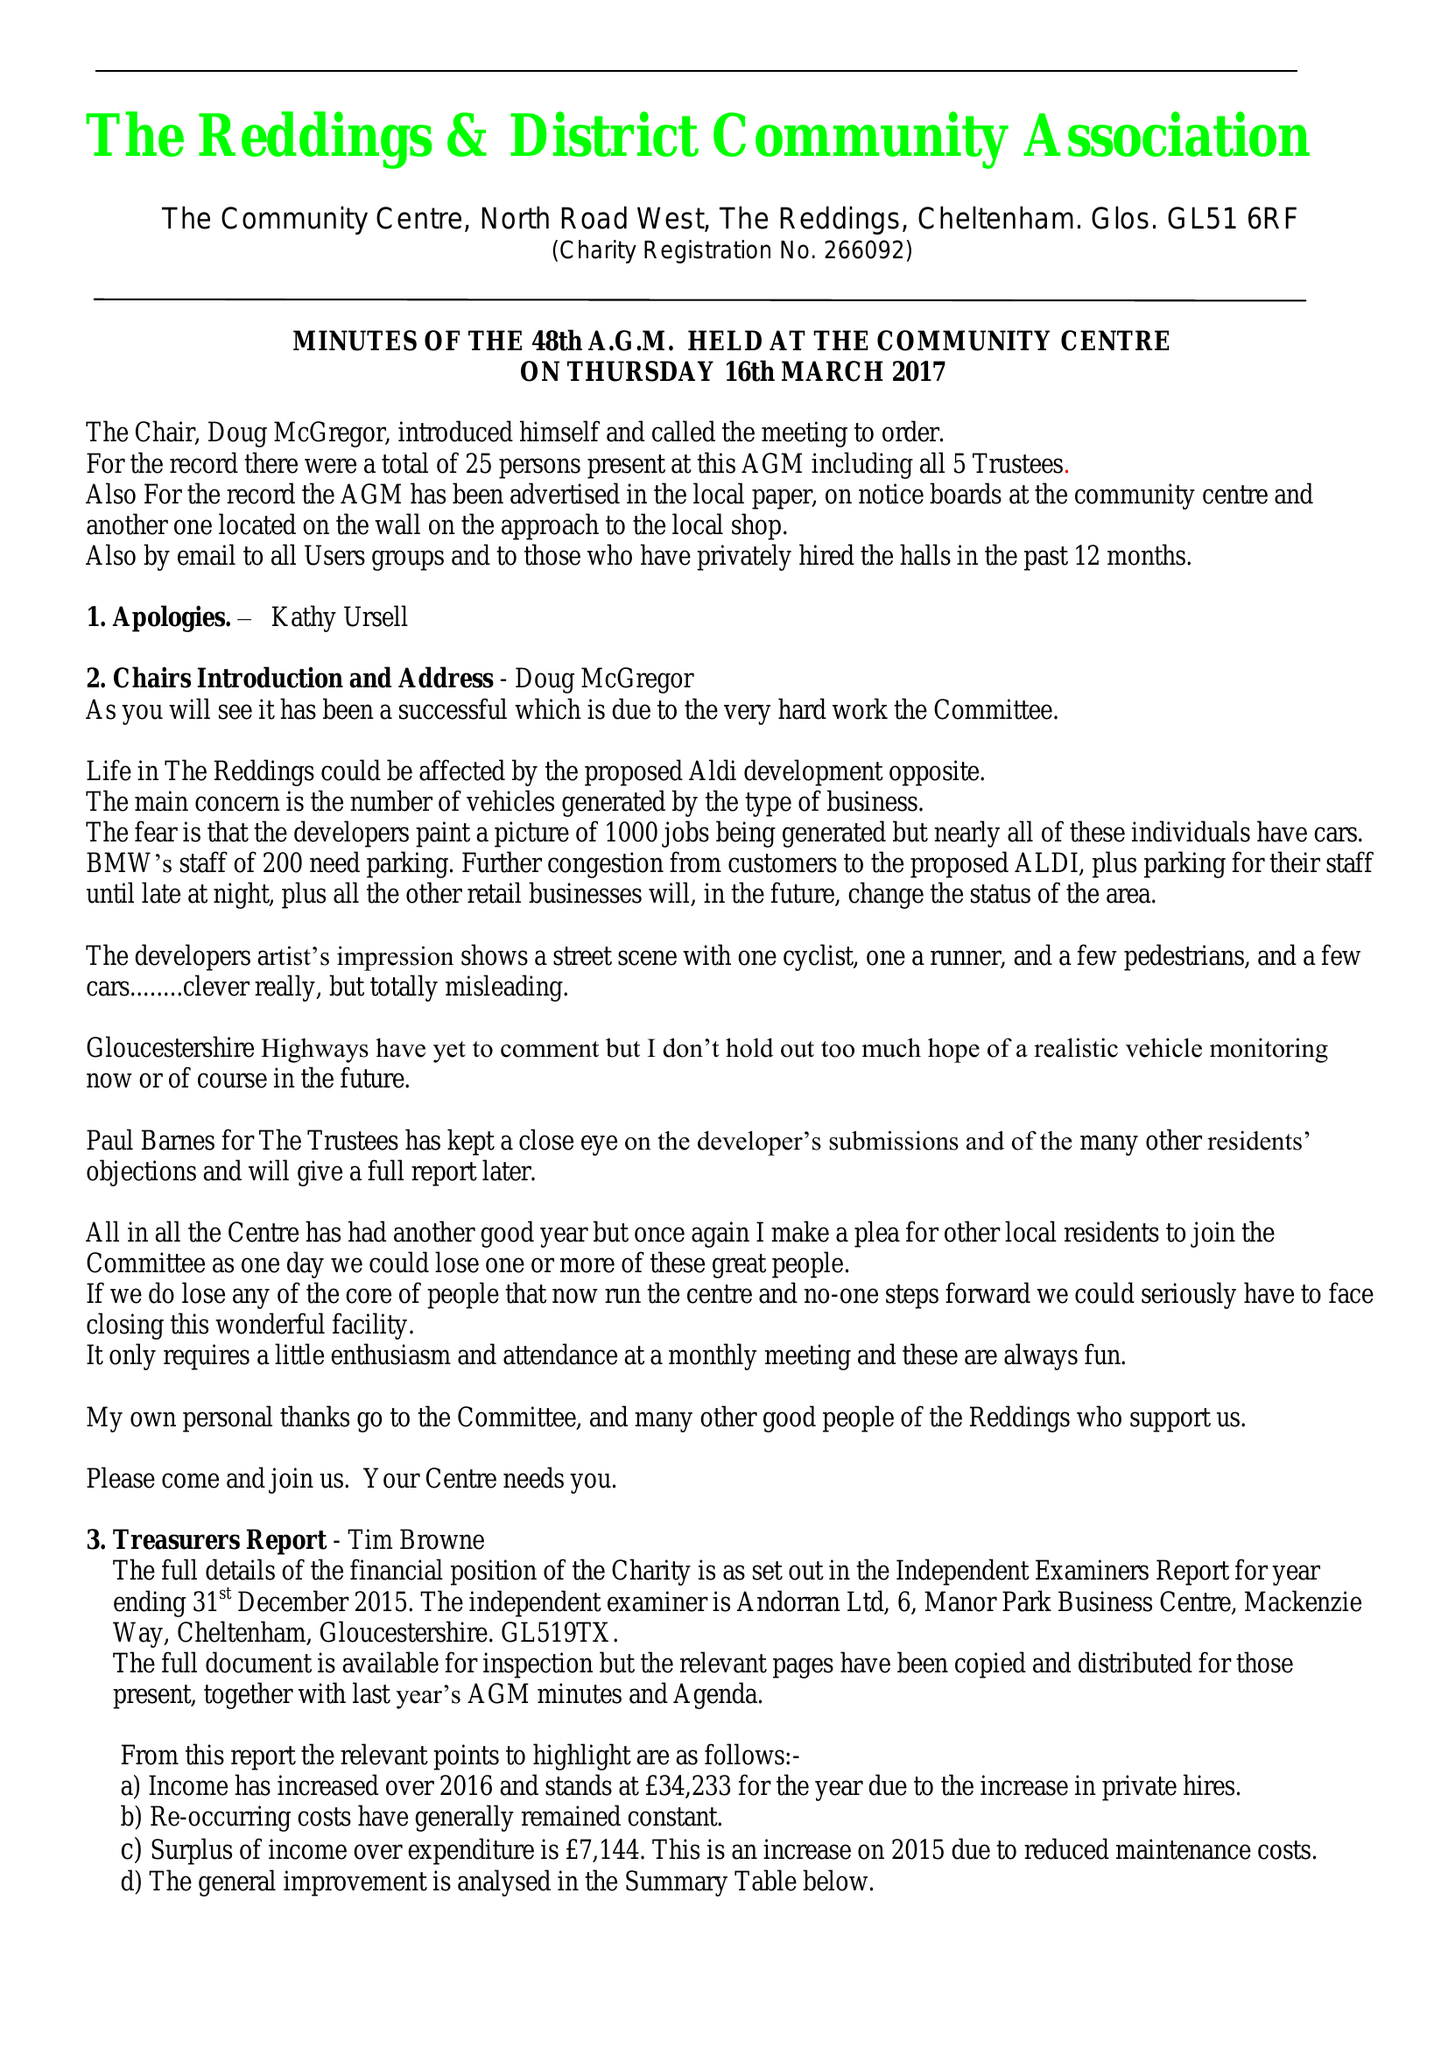What is the value for the spending_annually_in_british_pounds?
Answer the question using a single word or phrase. 27098.00 